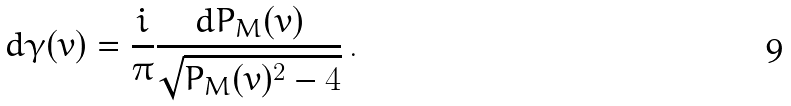<formula> <loc_0><loc_0><loc_500><loc_500>d \gamma ( v ) = \frac { i } { \pi } \frac { d P _ { M } ( v ) } { \sqrt { P _ { M } ( v ) ^ { 2 } - 4 } } \, .</formula> 